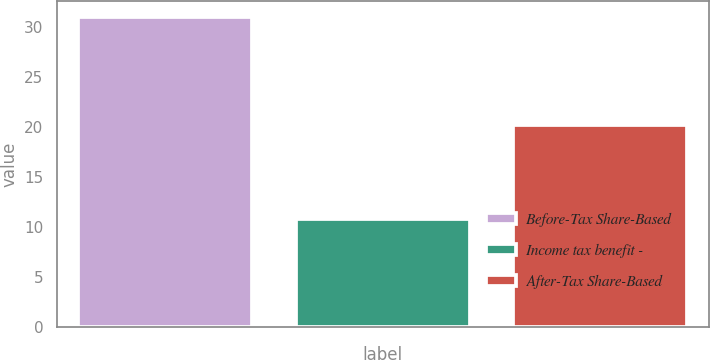Convert chart. <chart><loc_0><loc_0><loc_500><loc_500><bar_chart><fcel>Before-Tax Share-Based<fcel>Income tax benefit -<fcel>After-Tax Share-Based<nl><fcel>31<fcel>10.8<fcel>20.2<nl></chart> 